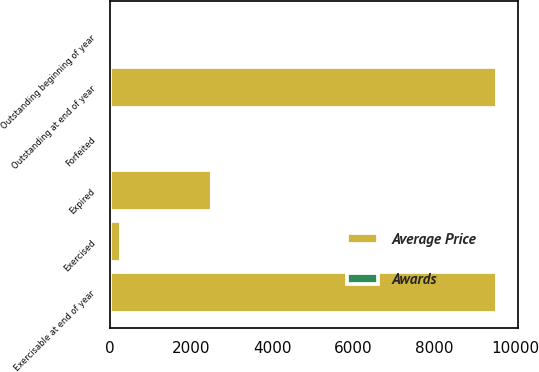Convert chart. <chart><loc_0><loc_0><loc_500><loc_500><stacked_bar_chart><ecel><fcel>Outstanding beginning of year<fcel>Exercised<fcel>Forfeited<fcel>Expired<fcel>Outstanding at end of year<fcel>Exercisable at end of year<nl><fcel>Average Price<fcel>29.37<fcel>266<fcel>50<fcel>2511<fcel>9547<fcel>9547<nl><fcel>Awards<fcel>27.36<fcel>19.18<fcel>27.43<fcel>29.37<fcel>27.19<fcel>27.19<nl></chart> 